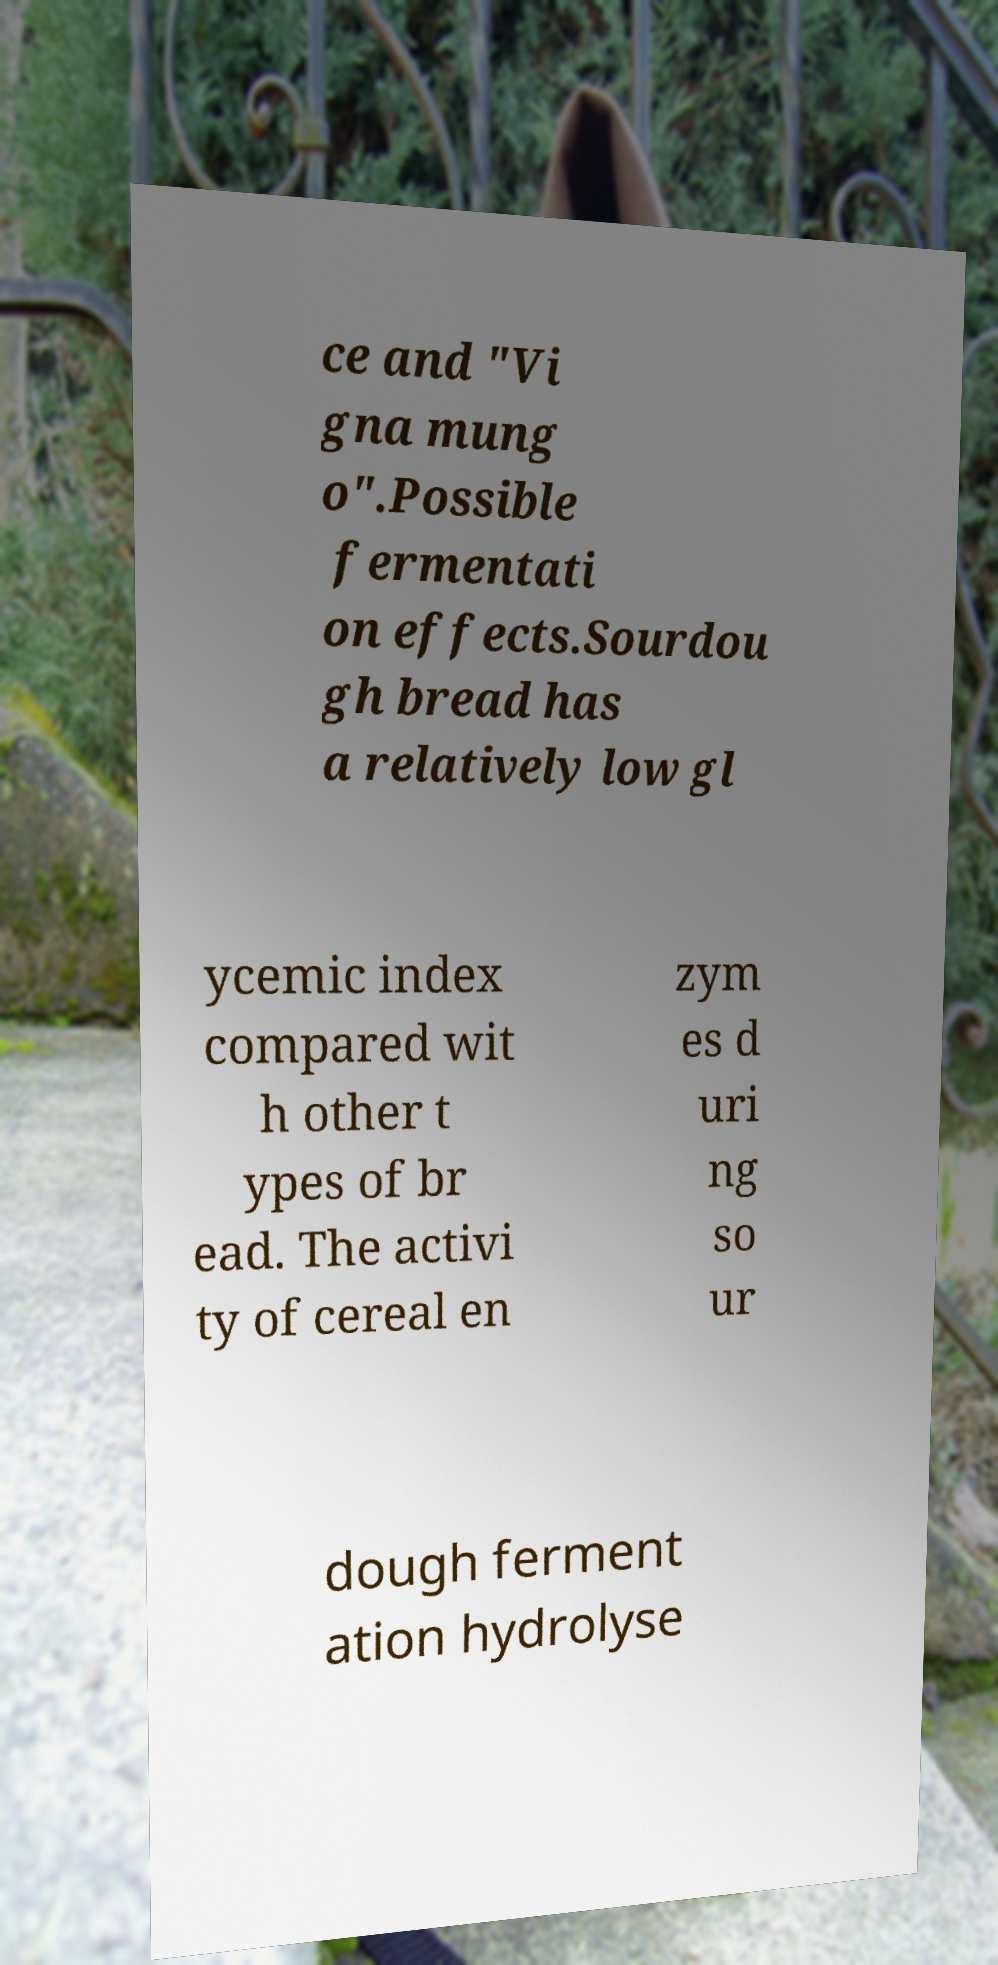What messages or text are displayed in this image? I need them in a readable, typed format. ce and "Vi gna mung o".Possible fermentati on effects.Sourdou gh bread has a relatively low gl ycemic index compared wit h other t ypes of br ead. The activi ty of cereal en zym es d uri ng so ur dough ferment ation hydrolyse 